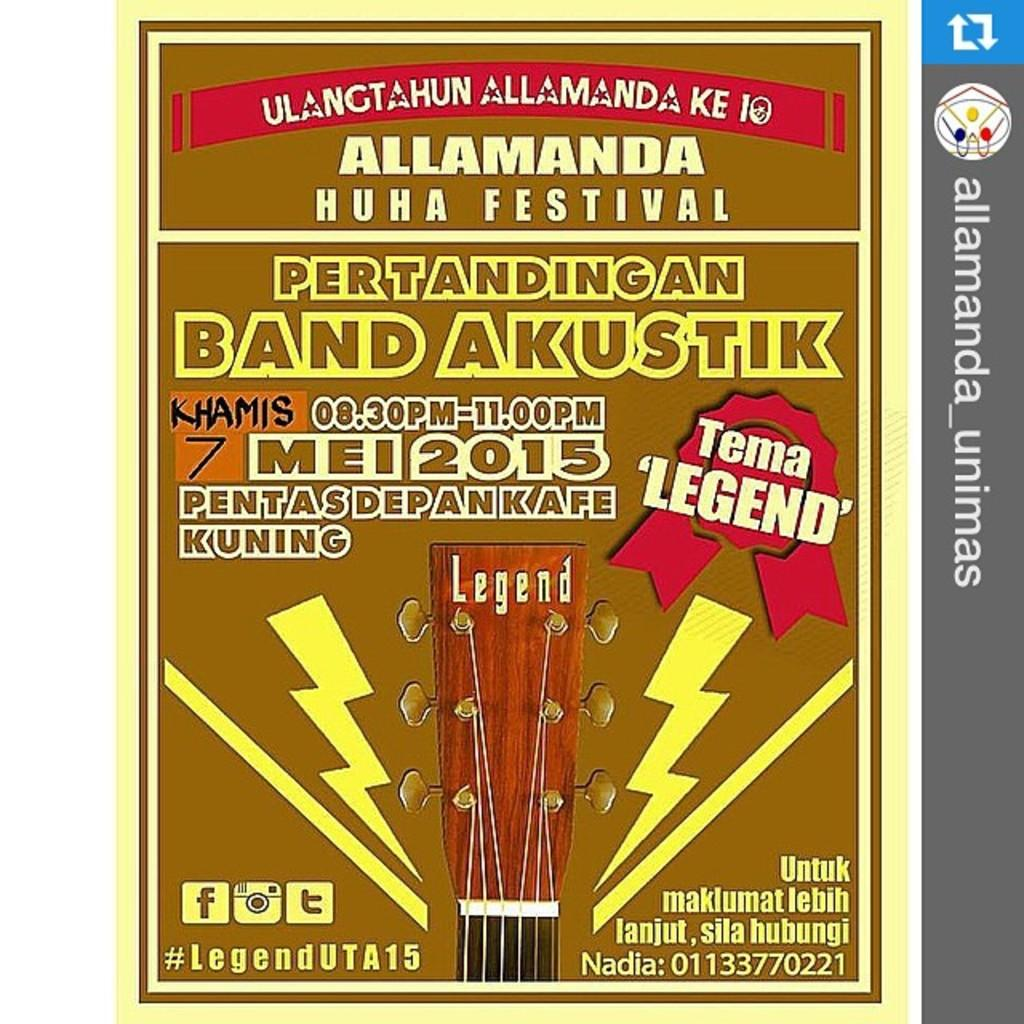What can be seen hanging on the wall in the image? There is a poster in the image. What is written or displayed on the poster? There is text printed on the poster. Can you see your grandmother's toes in the image? There is no reference to a grandmother or toes in the image; it only features a poster with text. 